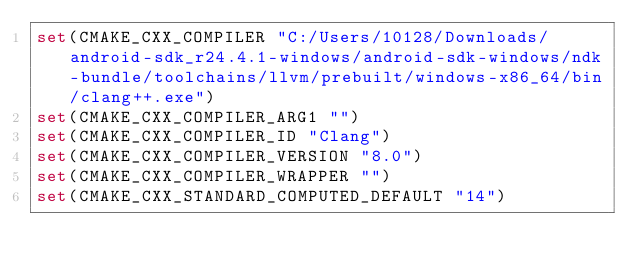Convert code to text. <code><loc_0><loc_0><loc_500><loc_500><_CMake_>set(CMAKE_CXX_COMPILER "C:/Users/10128/Downloads/android-sdk_r24.4.1-windows/android-sdk-windows/ndk-bundle/toolchains/llvm/prebuilt/windows-x86_64/bin/clang++.exe")
set(CMAKE_CXX_COMPILER_ARG1 "")
set(CMAKE_CXX_COMPILER_ID "Clang")
set(CMAKE_CXX_COMPILER_VERSION "8.0")
set(CMAKE_CXX_COMPILER_WRAPPER "")
set(CMAKE_CXX_STANDARD_COMPUTED_DEFAULT "14")</code> 